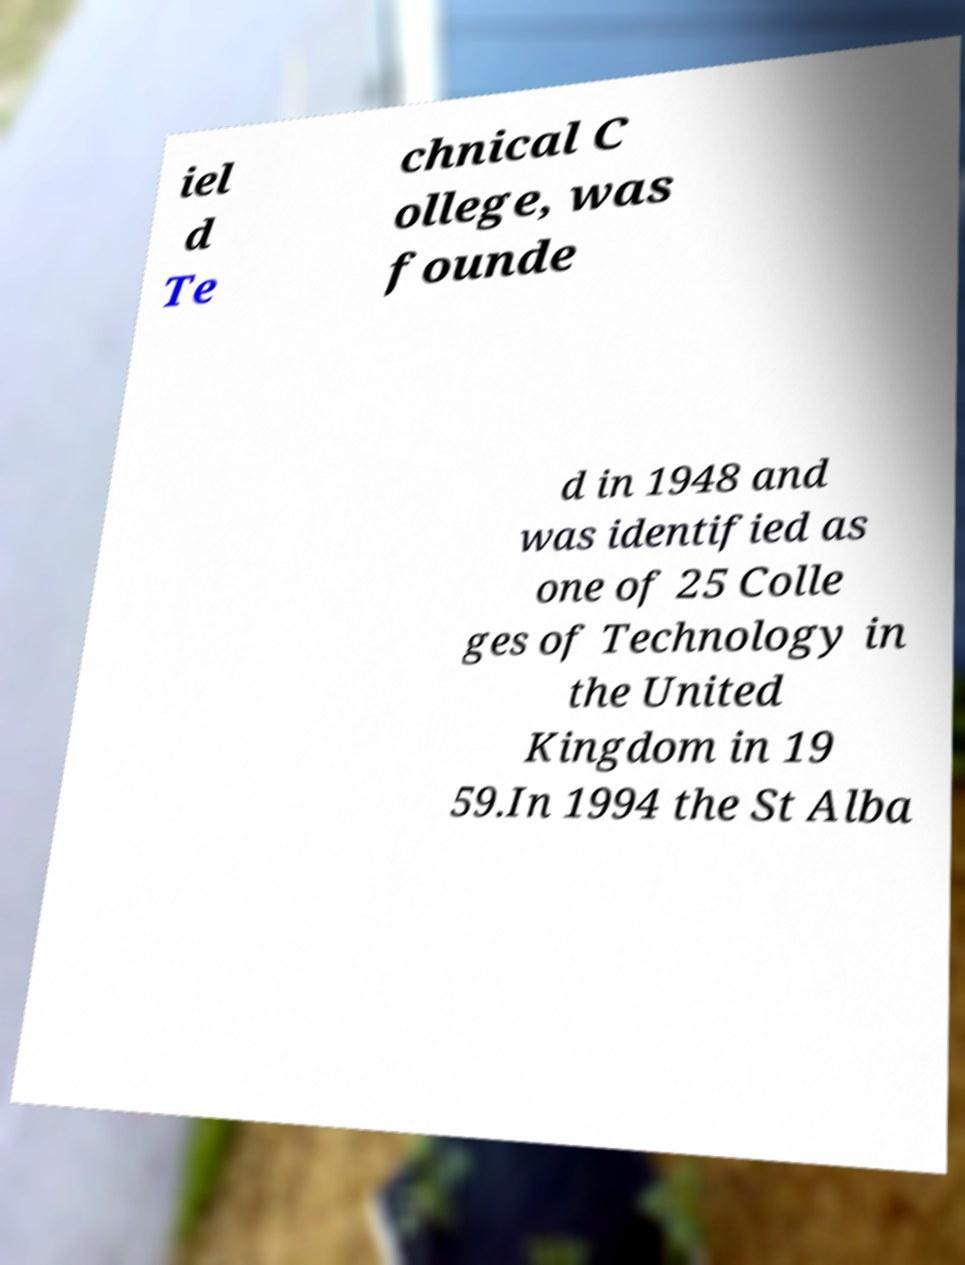Please identify and transcribe the text found in this image. iel d Te chnical C ollege, was founde d in 1948 and was identified as one of 25 Colle ges of Technology in the United Kingdom in 19 59.In 1994 the St Alba 